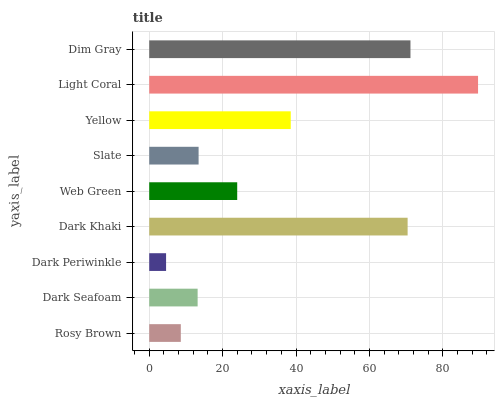Is Dark Periwinkle the minimum?
Answer yes or no. Yes. Is Light Coral the maximum?
Answer yes or no. Yes. Is Dark Seafoam the minimum?
Answer yes or no. No. Is Dark Seafoam the maximum?
Answer yes or no. No. Is Dark Seafoam greater than Rosy Brown?
Answer yes or no. Yes. Is Rosy Brown less than Dark Seafoam?
Answer yes or no. Yes. Is Rosy Brown greater than Dark Seafoam?
Answer yes or no. No. Is Dark Seafoam less than Rosy Brown?
Answer yes or no. No. Is Web Green the high median?
Answer yes or no. Yes. Is Web Green the low median?
Answer yes or no. Yes. Is Light Coral the high median?
Answer yes or no. No. Is Slate the low median?
Answer yes or no. No. 